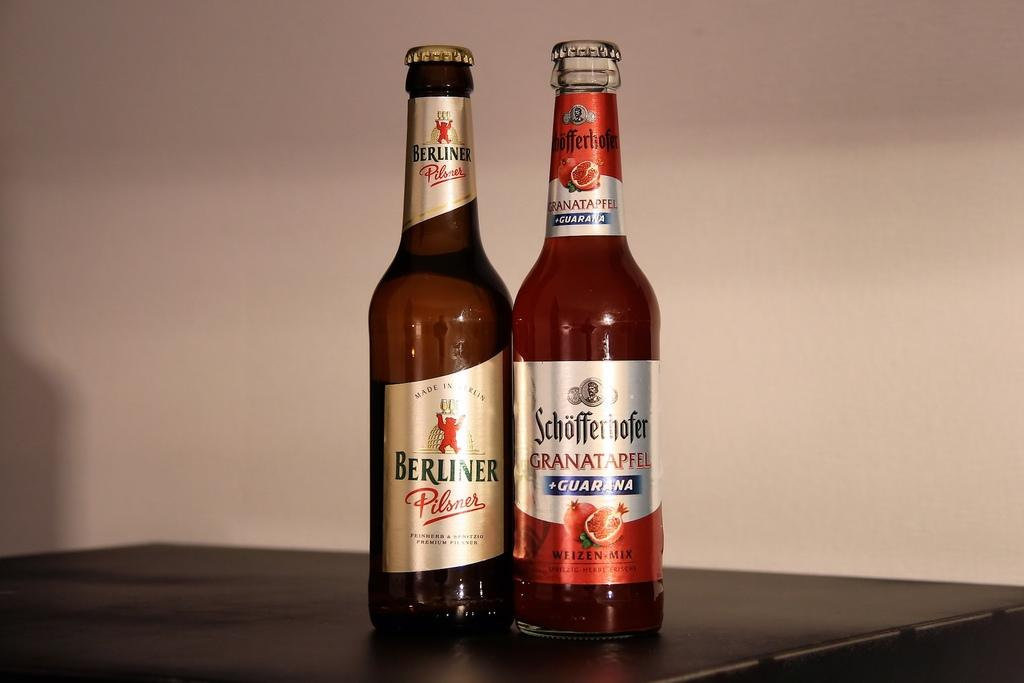What objects are on the table in the image? There are bottles on a table in the image. What can be seen in the background of the image? There is a wall in the background of the image. What type of collar can be seen on the guitar in the image? There is no guitar present in the image, so there is no collar to be seen. 